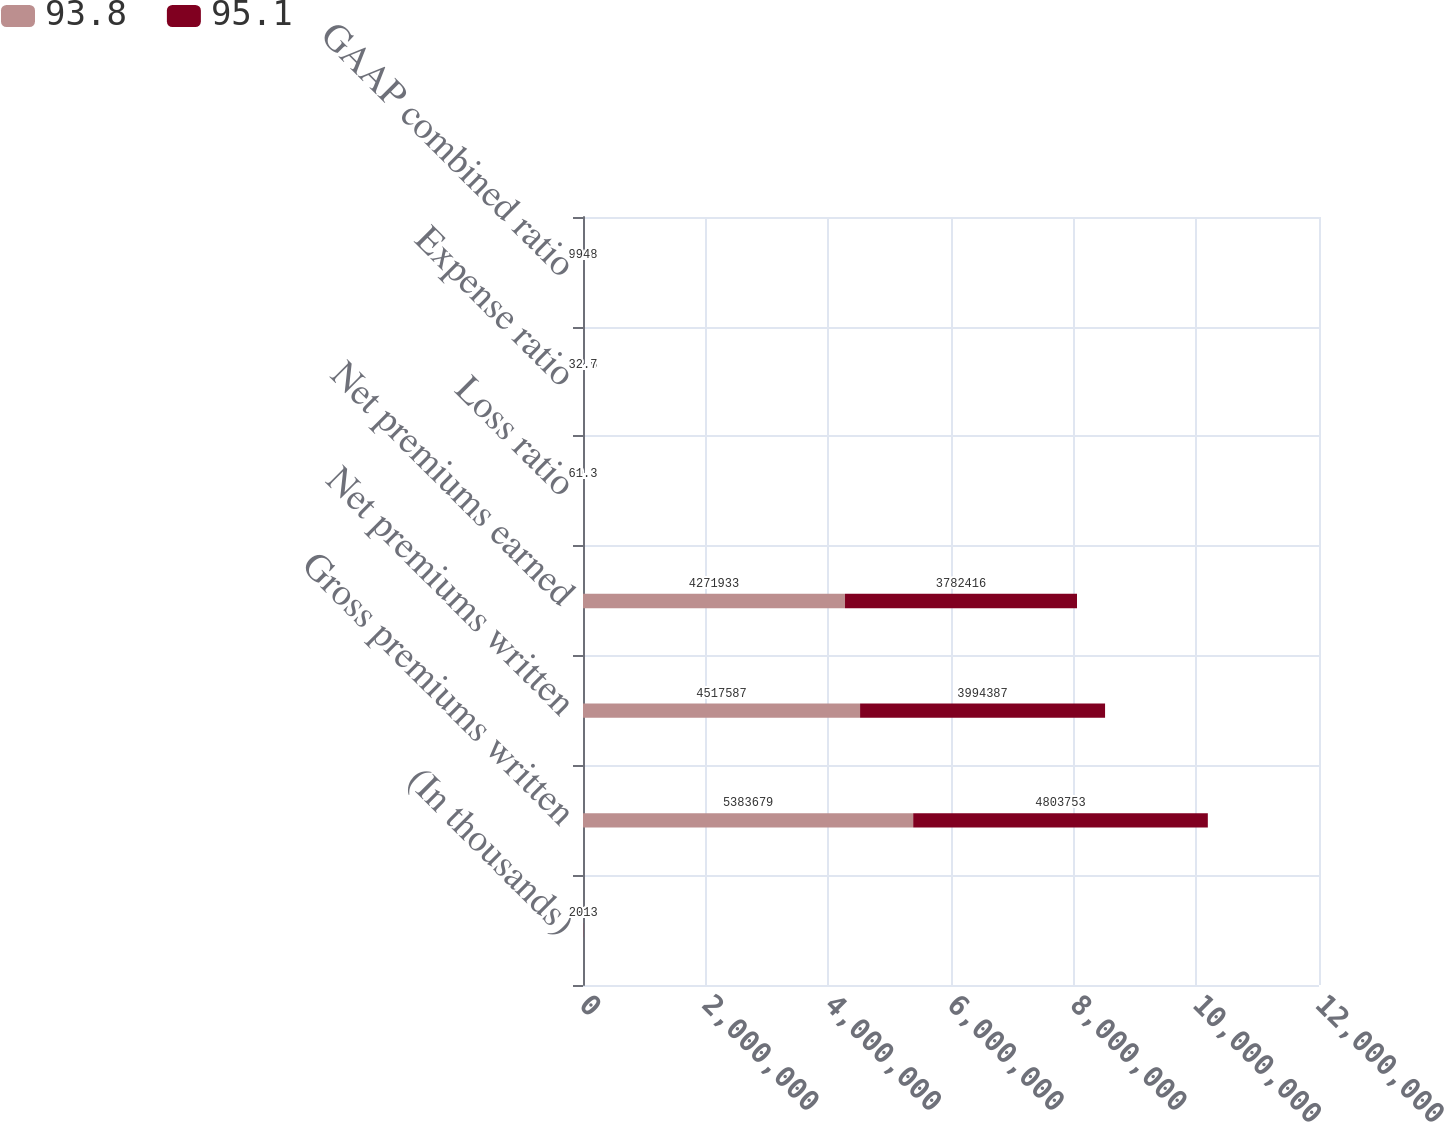Convert chart to OTSL. <chart><loc_0><loc_0><loc_500><loc_500><stacked_bar_chart><ecel><fcel>(In thousands)<fcel>Gross premiums written<fcel>Net premiums written<fcel>Net premiums earned<fcel>Loss ratio<fcel>Expense ratio<fcel>GAAP combined ratio<nl><fcel>93.8<fcel>2014<fcel>5.38368e+06<fcel>4.51759e+06<fcel>4.27193e+06<fcel>60.2<fcel>31.6<fcel>91.8<nl><fcel>95.1<fcel>2013<fcel>4.80375e+06<fcel>3.99439e+06<fcel>3.78242e+06<fcel>61.3<fcel>32.7<fcel>94<nl></chart> 